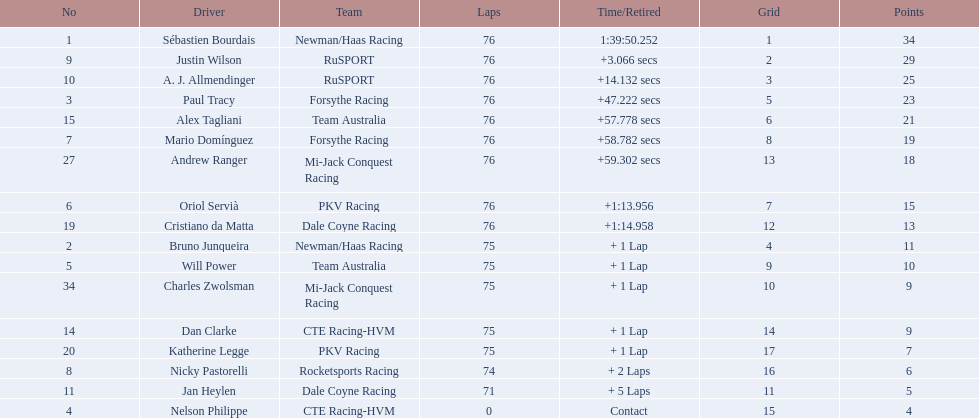What was alex taglini's final score in the tecate grand prix? 21. What was paul tracy's final score in the tecate grand prix? 23. Which driver finished first? Paul Tracy. 